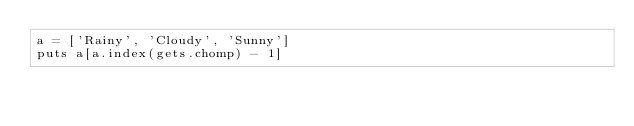Convert code to text. <code><loc_0><loc_0><loc_500><loc_500><_Ruby_>a = ['Rainy', 'Cloudy', 'Sunny']
puts a[a.index(gets.chomp) - 1]</code> 